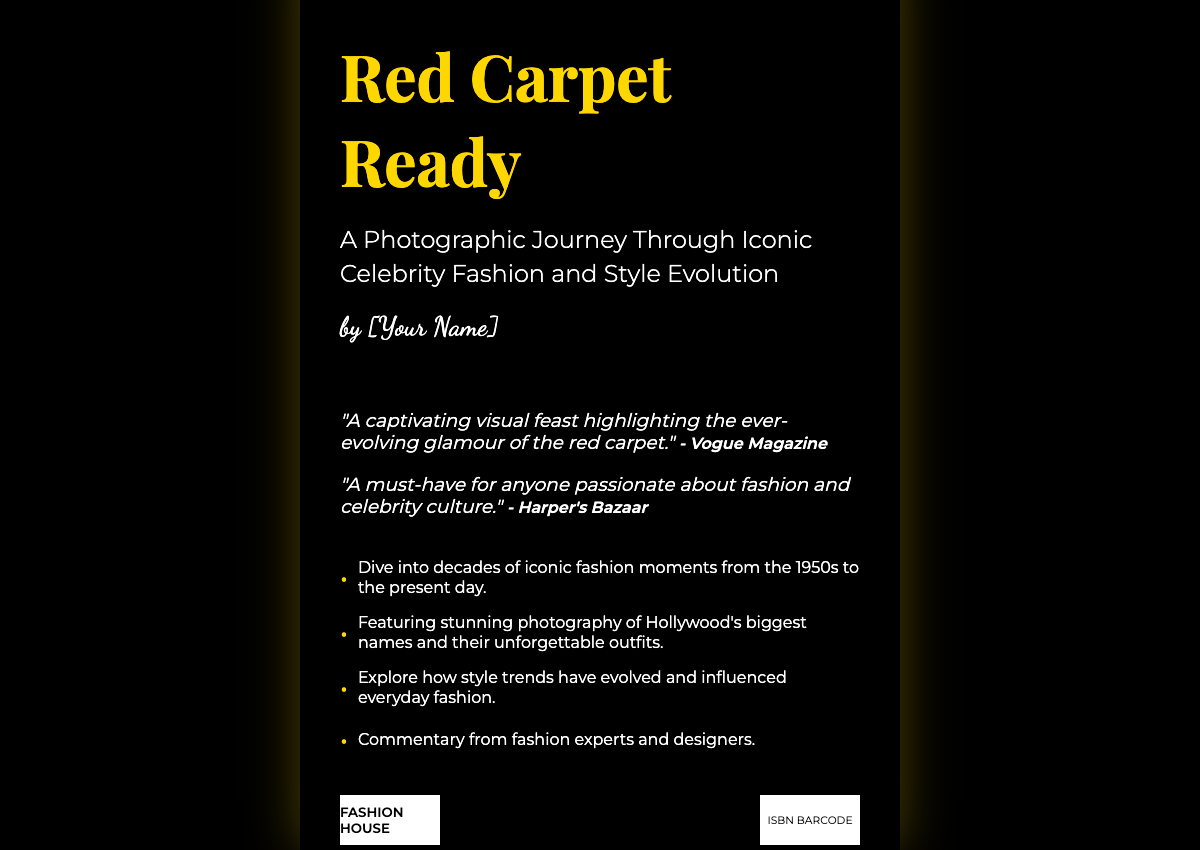What is the title of the book? The title is prominently displayed at the top of the cover.
Answer: Red Carpet Ready What is the subtitle of the book? The subtitle provides additional context about the book's content.
Answer: A Photographic Journey Through Iconic Celebrity Fashion and Style Evolution Who is the author? The author's name is mentioned near the bottom of the cover.
Answer: [Your Name] What magazine provided a blurb for the book? A prominent fashion magazine cited on the cover praises the book.
Answer: Vogue Magazine What decade does the book cover start with? The highlights mention the range of fashion moments featured in the book.
Answer: 1950s How many highlights are listed? The highlights section includes bullet points summarizing key features of the book.
Answer: Four What type of visual content is featured in the book? The subtitle indicates the type of content the reader can expect.
Answer: Photographic What is the name of the publisher? The publisher's information is displayed at the bottom of the cover.
Answer: FASHION HOUSE What genre does the book belong to? The combination of fashion and celebrity themes indicates its genre.
Answer: Fashion and Style 